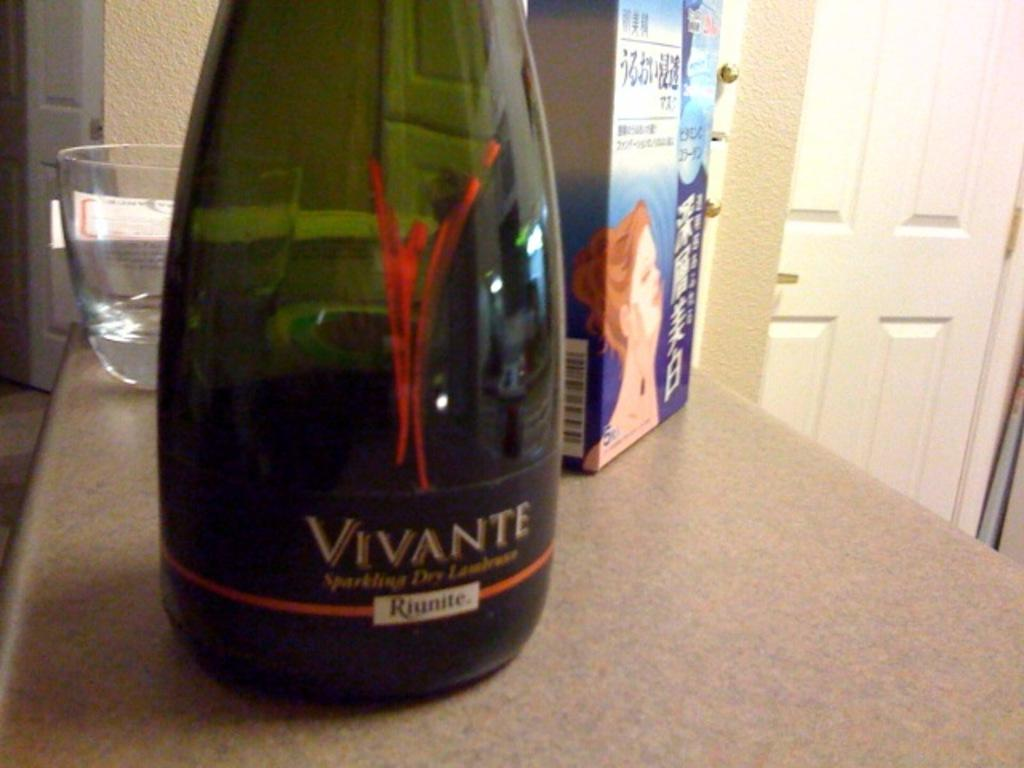<image>
Provide a brief description of the given image. A bottle of wine which has Vivante written on the label. 